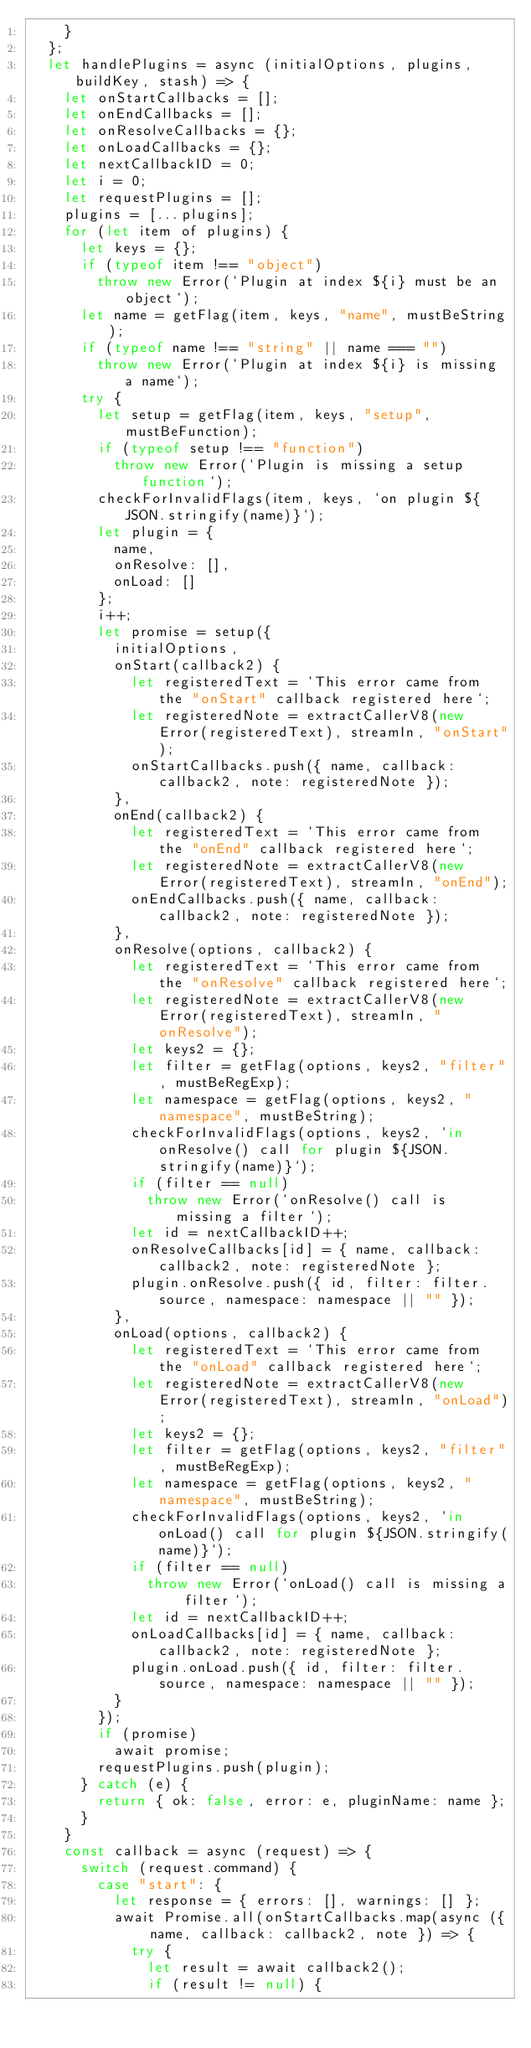<code> <loc_0><loc_0><loc_500><loc_500><_JavaScript_>    }
  };
  let handlePlugins = async (initialOptions, plugins, buildKey, stash) => {
    let onStartCallbacks = [];
    let onEndCallbacks = [];
    let onResolveCallbacks = {};
    let onLoadCallbacks = {};
    let nextCallbackID = 0;
    let i = 0;
    let requestPlugins = [];
    plugins = [...plugins];
    for (let item of plugins) {
      let keys = {};
      if (typeof item !== "object")
        throw new Error(`Plugin at index ${i} must be an object`);
      let name = getFlag(item, keys, "name", mustBeString);
      if (typeof name !== "string" || name === "")
        throw new Error(`Plugin at index ${i} is missing a name`);
      try {
        let setup = getFlag(item, keys, "setup", mustBeFunction);
        if (typeof setup !== "function")
          throw new Error(`Plugin is missing a setup function`);
        checkForInvalidFlags(item, keys, `on plugin ${JSON.stringify(name)}`);
        let plugin = {
          name,
          onResolve: [],
          onLoad: []
        };
        i++;
        let promise = setup({
          initialOptions,
          onStart(callback2) {
            let registeredText = `This error came from the "onStart" callback registered here`;
            let registeredNote = extractCallerV8(new Error(registeredText), streamIn, "onStart");
            onStartCallbacks.push({ name, callback: callback2, note: registeredNote });
          },
          onEnd(callback2) {
            let registeredText = `This error came from the "onEnd" callback registered here`;
            let registeredNote = extractCallerV8(new Error(registeredText), streamIn, "onEnd");
            onEndCallbacks.push({ name, callback: callback2, note: registeredNote });
          },
          onResolve(options, callback2) {
            let registeredText = `This error came from the "onResolve" callback registered here`;
            let registeredNote = extractCallerV8(new Error(registeredText), streamIn, "onResolve");
            let keys2 = {};
            let filter = getFlag(options, keys2, "filter", mustBeRegExp);
            let namespace = getFlag(options, keys2, "namespace", mustBeString);
            checkForInvalidFlags(options, keys2, `in onResolve() call for plugin ${JSON.stringify(name)}`);
            if (filter == null)
              throw new Error(`onResolve() call is missing a filter`);
            let id = nextCallbackID++;
            onResolveCallbacks[id] = { name, callback: callback2, note: registeredNote };
            plugin.onResolve.push({ id, filter: filter.source, namespace: namespace || "" });
          },
          onLoad(options, callback2) {
            let registeredText = `This error came from the "onLoad" callback registered here`;
            let registeredNote = extractCallerV8(new Error(registeredText), streamIn, "onLoad");
            let keys2 = {};
            let filter = getFlag(options, keys2, "filter", mustBeRegExp);
            let namespace = getFlag(options, keys2, "namespace", mustBeString);
            checkForInvalidFlags(options, keys2, `in onLoad() call for plugin ${JSON.stringify(name)}`);
            if (filter == null)
              throw new Error(`onLoad() call is missing a filter`);
            let id = nextCallbackID++;
            onLoadCallbacks[id] = { name, callback: callback2, note: registeredNote };
            plugin.onLoad.push({ id, filter: filter.source, namespace: namespace || "" });
          }
        });
        if (promise)
          await promise;
        requestPlugins.push(plugin);
      } catch (e) {
        return { ok: false, error: e, pluginName: name };
      }
    }
    const callback = async (request) => {
      switch (request.command) {
        case "start": {
          let response = { errors: [], warnings: [] };
          await Promise.all(onStartCallbacks.map(async ({ name, callback: callback2, note }) => {
            try {
              let result = await callback2();
              if (result != null) {</code> 